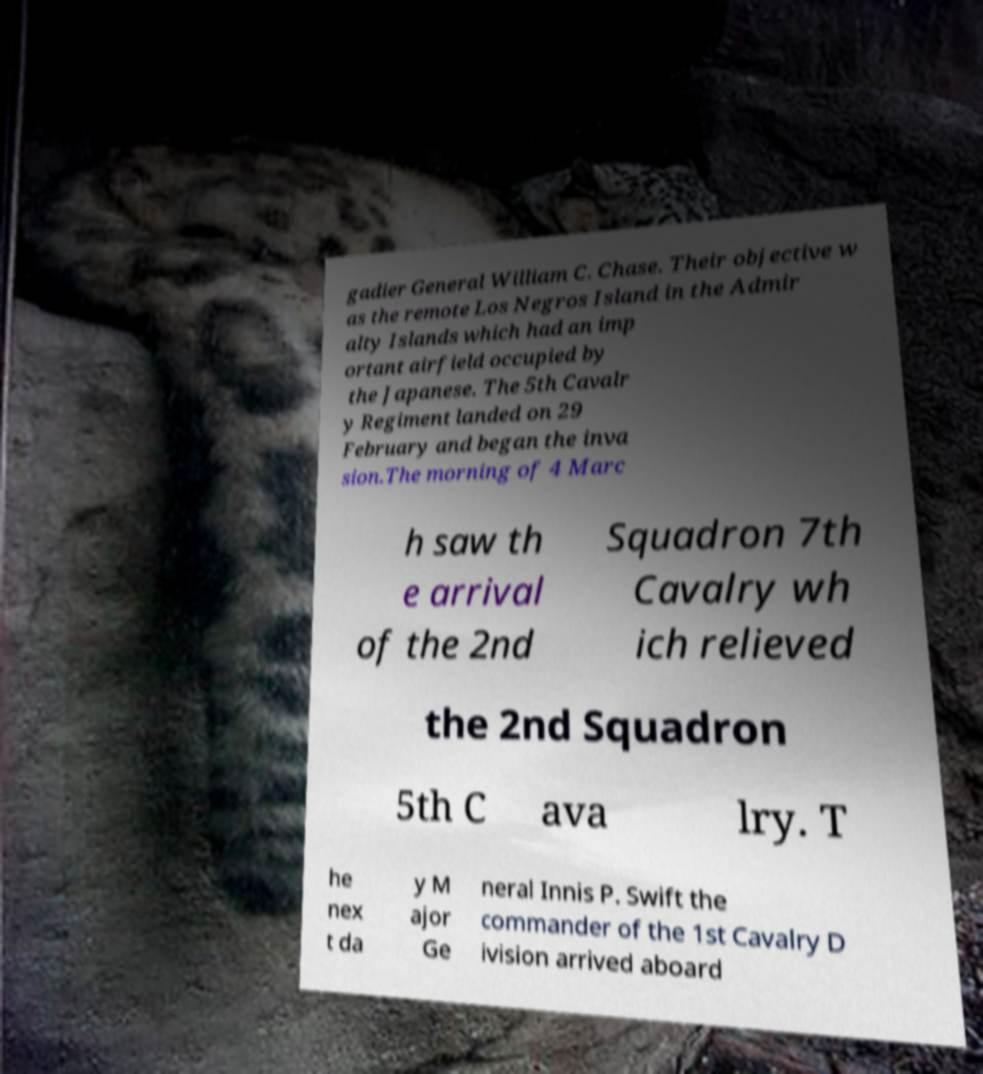Could you assist in decoding the text presented in this image and type it out clearly? gadier General William C. Chase. Their objective w as the remote Los Negros Island in the Admir alty Islands which had an imp ortant airfield occupied by the Japanese. The 5th Cavalr y Regiment landed on 29 February and began the inva sion.The morning of 4 Marc h saw th e arrival of the 2nd Squadron 7th Cavalry wh ich relieved the 2nd Squadron 5th C ava lry. T he nex t da y M ajor Ge neral Innis P. Swift the commander of the 1st Cavalry D ivision arrived aboard 